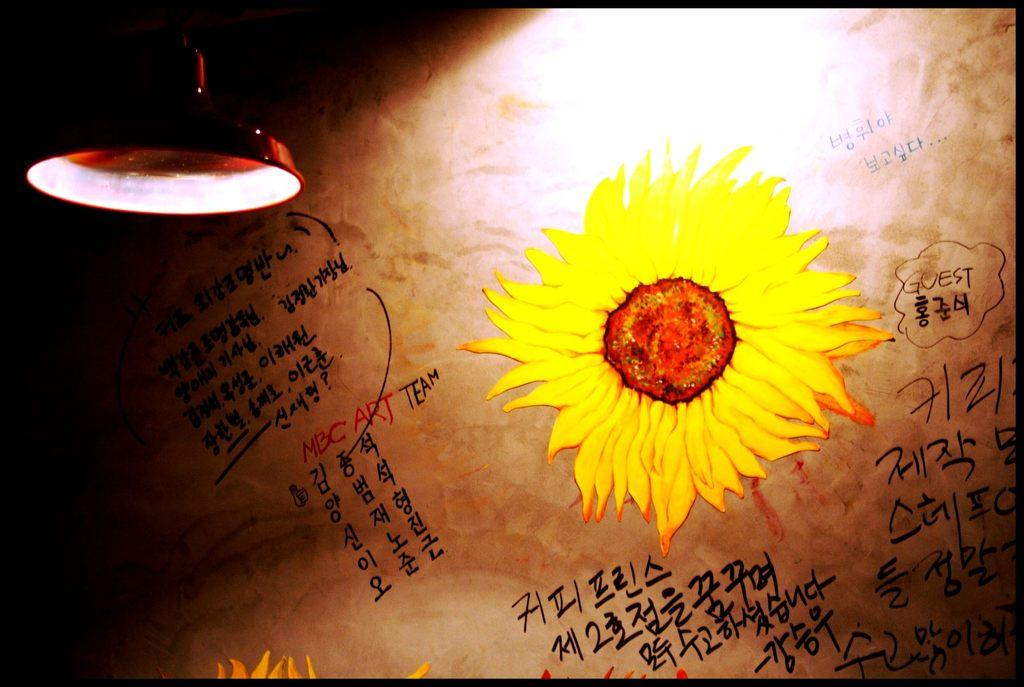What can be seen in the image that provides illumination? There is a light in the image. What is hanging on the wall in the image? There is a poster in the image. What is depicted on the poster? The poster contains a picture of a flower. What else is present on the poster besides the flower image? Text is written on the poster. What type of art can be seen on the scale in the image? There is no scale or art present in the image. How many pears are visible on the poster in the image? There are no pears depicted on the poster; it features a picture of a flower. 